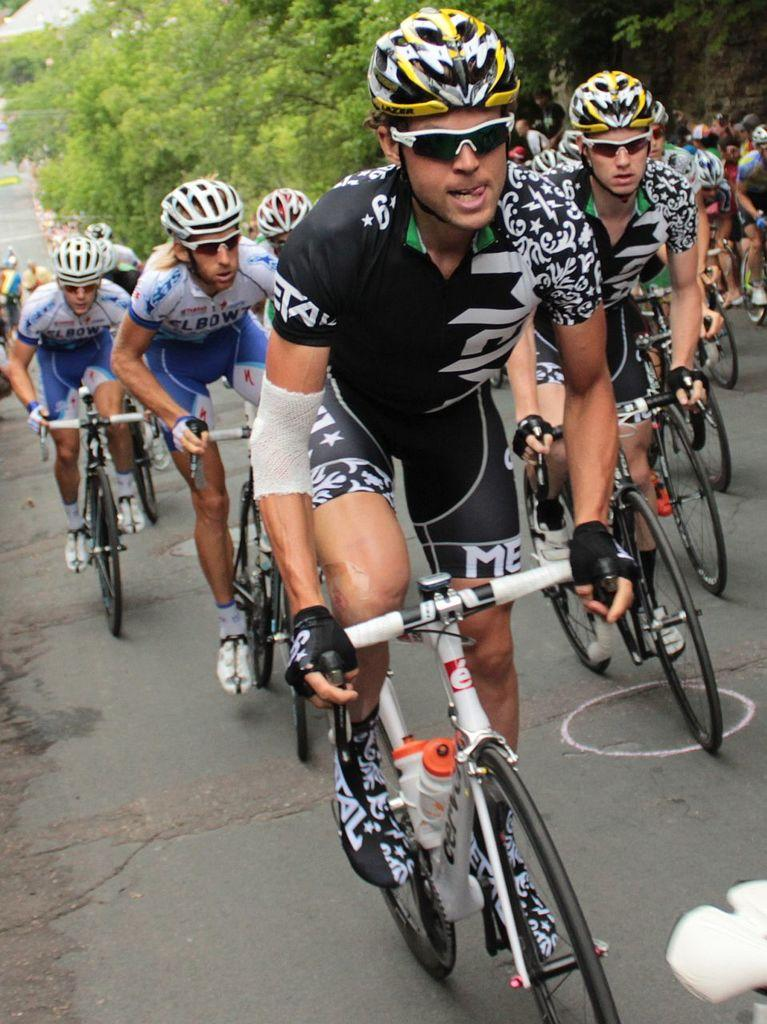What are the people in the image doing? The people in the image are riding bikes. Where are the bikes located? The bikes are on a road. What can be seen behind the group of people? There is a crowd behind the group of people, and plenty of trees behind the crowd. Who is sitting on the throne in the image? There is no throne present in the image. How many shoes can be seen on the bikes in the image? The image does not show any shoes on the bikes; it only shows the bikes and the people riding them. 